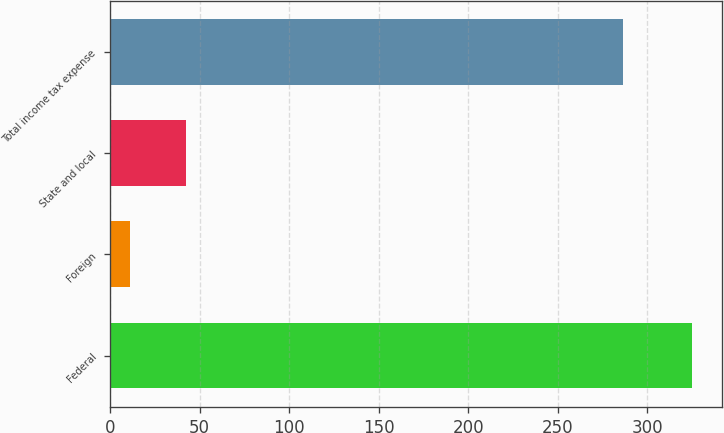Convert chart to OTSL. <chart><loc_0><loc_0><loc_500><loc_500><bar_chart><fcel>Federal<fcel>Foreign<fcel>State and local<fcel>Total income tax expense<nl><fcel>325.1<fcel>11<fcel>42.41<fcel>286.1<nl></chart> 